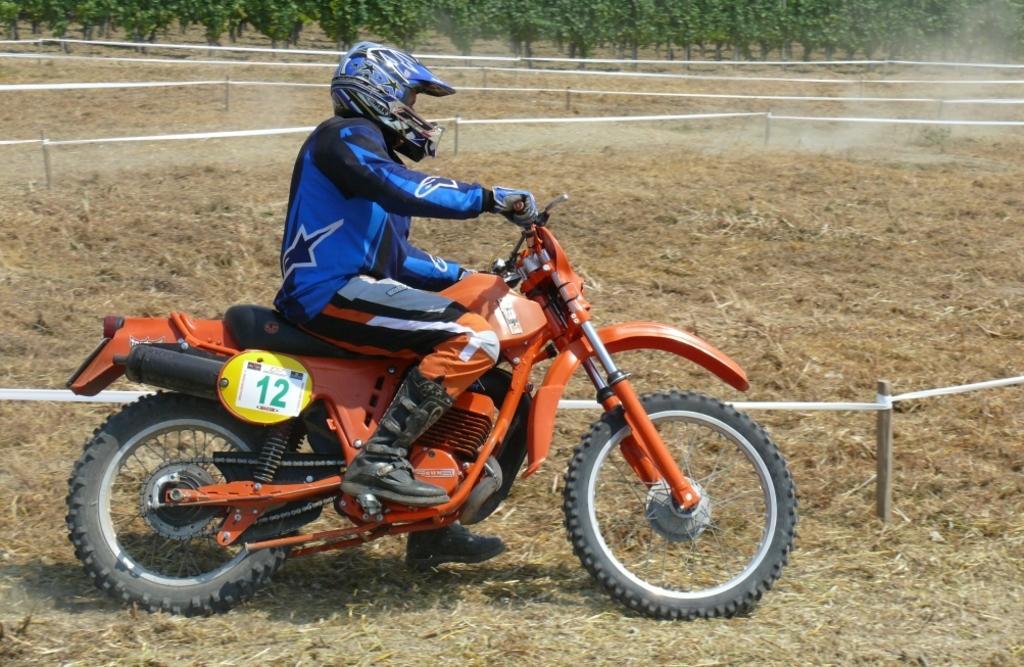How would you summarize this image in a sentence or two? A man is riding the sports bike, it is in orange color. He wore blue color dress, helmet. There are trees at the top of this image. 